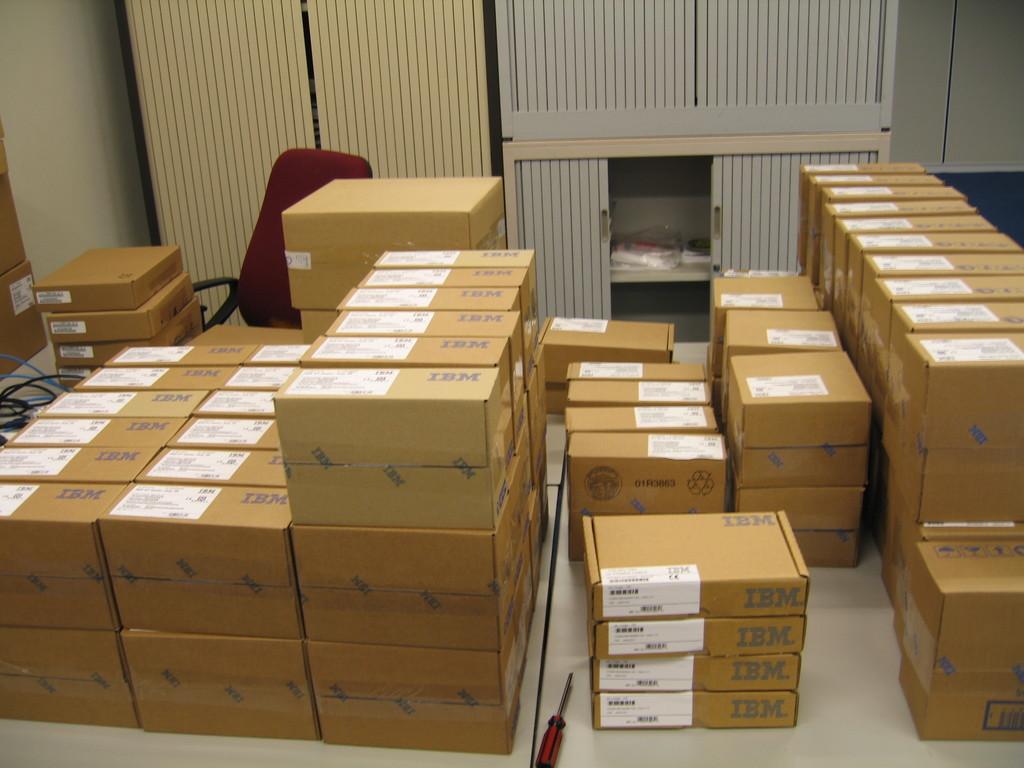What company made the products in these boxes?
Your answer should be compact. Ibm. 